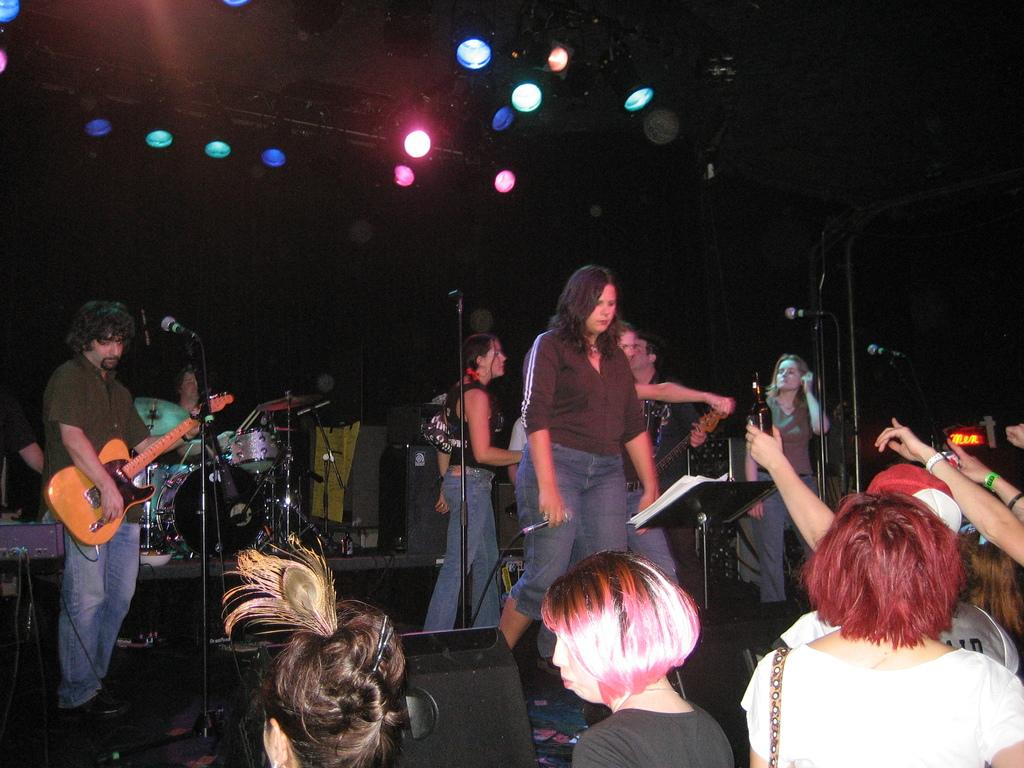What is happening on stage in the image? There are people standing on stage in the image. What are some of the people on stage holding? Some people on stage are holding guitars. What other musical instruments can be seen on stage? There are musical drums present on stage. What type of coal is being used to fuel the instruments on stage? There is no coal present in the image, and instruments do not require coal to function. 